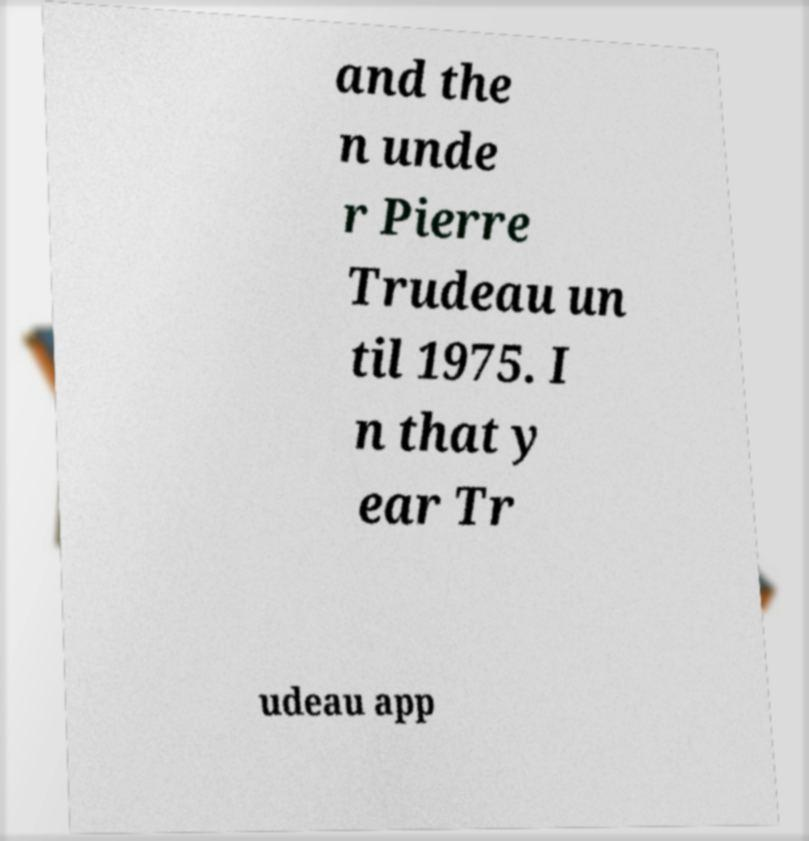Please read and relay the text visible in this image. What does it say? and the n unde r Pierre Trudeau un til 1975. I n that y ear Tr udeau app 